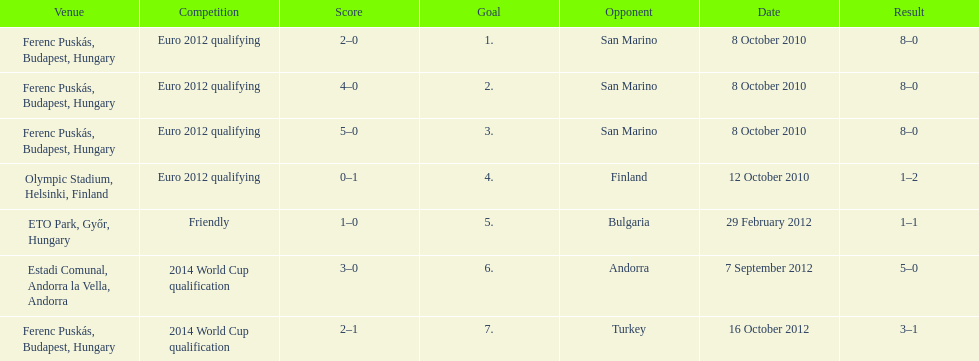How many games did he score but his team lost? 1. 